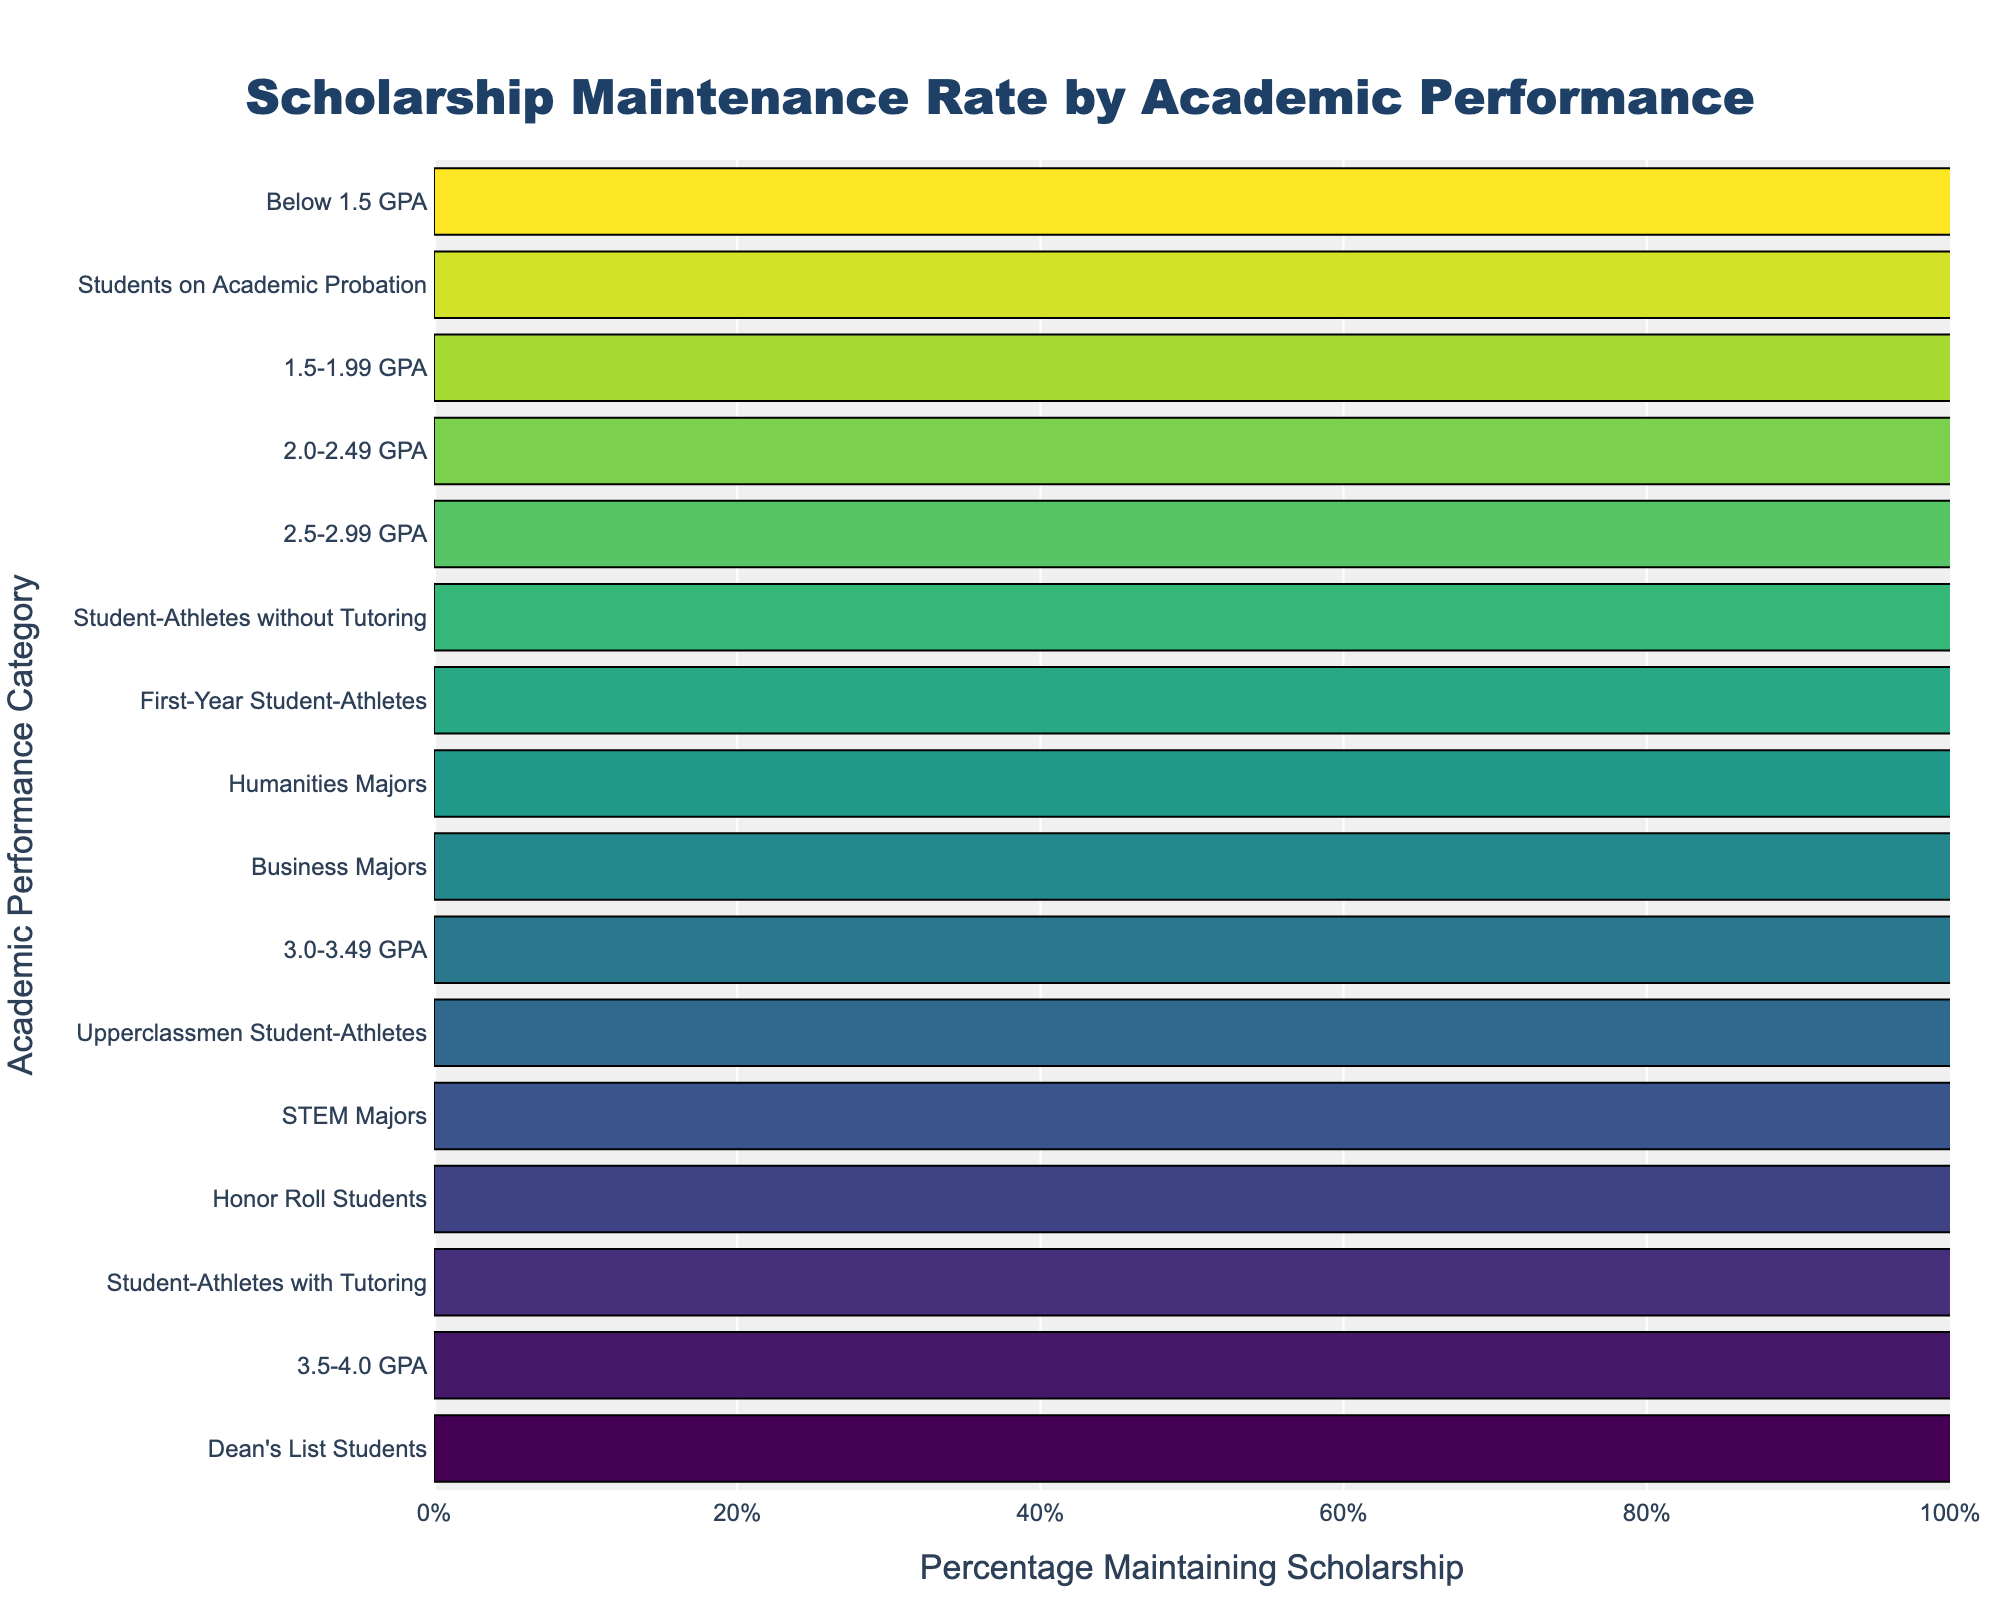What is the percentage of Dean's List Students who maintain their scholarships? Dean's List Students have a "Percentage Maintaining Scholarship" value of 98%.
Answer: 98% Which academic performance category has the lowest percentage of students maintaining their scholarships? The category "Below 1.5 GPA" has the lowest percentage of students maintaining their scholarships, indicated by a value of 23%.
Answer: Below 1.5 GPA Compare the percentage of student-athletes with tutoring who maintain their scholarships to those without tutoring. The percentage for student-athletes with tutoring is 93%, while for those without tutoring it is 79%.
Answer: Student-athletes with tutoring: 93%, Student-athletes without tutoring: 79% What is the difference in the percentage of students maintaining their scholarships between the 3.5-4.0 GPA category and the 2.0-2.49 GPA category? The "3.5-4.0 GPA" category has a percentage of 95%, and the "2.0-2.49 GPA" category has a percentage of 62%. The difference is 95% - 62% = 33%.
Answer: 33% How does the percentage of Honor Roll Students maintaining their scholarships compare to that of STEM Majors? Honor Roll Students have a percentage of 92%, whereas STEM Majors have a percentage of 91%.
Answer: Honor Roll Students: 92%, STEM Majors: 91% What is the average percentage of scholarships maintained for the categories of Business Majors, Humanities Majors, and STEM Majors? The percentages are as follows: Business Majors (88%), Humanities Majors (86%), and STEM Majors (91%). The average is calculated as (88% + 86% + 91%) / 3 = 265% / 3 ≈ 88.33%.
Answer: 88.33% Which group has a higher percentage of maintaining their scholarships: First-Year Student-Athletes or Upperclassmen Student-Athletes? The percentage for First-Year Student-Athletes is 82%, while for Upperclassmen Student-Athletes it is 89%.
Answer: Upperclassmen Student-Athletes What is the range of percentages of students maintaining scholarships across all academic performance categories? The highest percentage is 98% (Dean's List Students) and the lowest is 23% (Below 1.5 GPA). The range is calculated as 98% - 23% = 75%.
Answer: 75% Which category has a higher percentage: Student-Athletes with Tutoring or the 3.0-3.49 GPA category? Student-Athletes with Tutoring have a percentage of 93%, while the 3.0-3.49 GPA category has a percentage of 88%.
Answer: Student-Athletes with Tutoring What is the median percentage of students maintaining scholarships for all listed categories? To find the median, list all percentages in ascending order: 23%, 38%, 45%, 62%, 76%, 79%, 82%, 86%, 88%, 88%, 89%, 91%, 92%, 93%, 95%, 98%. The middle values are 86% and 88%. The median is the average of these two values: (86% + 88%) / 2 = 87%.
Answer: 87% 